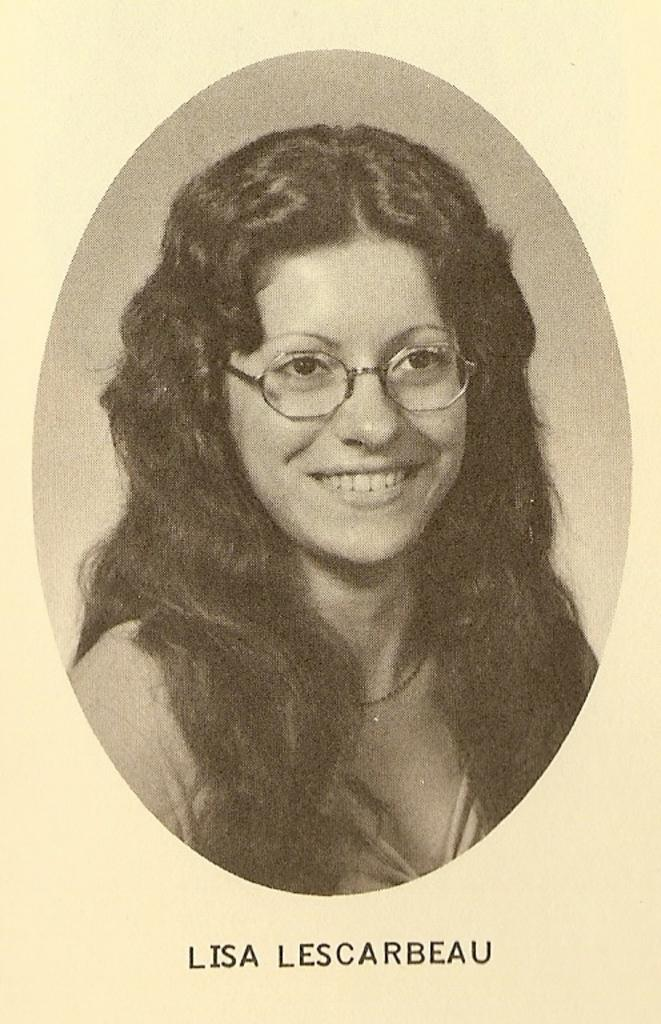What type of visual content is depicted in the image? The image is a poster. Who is featured on the poster? There is a woman on the poster. What is the woman doing in the poster? The woman is smiling. What accessory is the woman wearing in the poster? The woman is wearing spectacles. What type of coach is visible in the image? There is no coach present in the image; it is a poster featuring a woman. What role does zinc play in the image? Zinc is not mentioned or depicted in the image. 